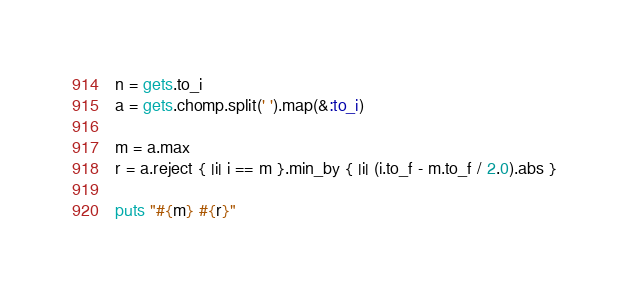Convert code to text. <code><loc_0><loc_0><loc_500><loc_500><_Ruby_>n = gets.to_i
a = gets.chomp.split(' ').map(&:to_i)

m = a.max
r = a.reject { |i| i == m }.min_by { |i| (i.to_f - m.to_f / 2.0).abs }

puts "#{m} #{r}"</code> 